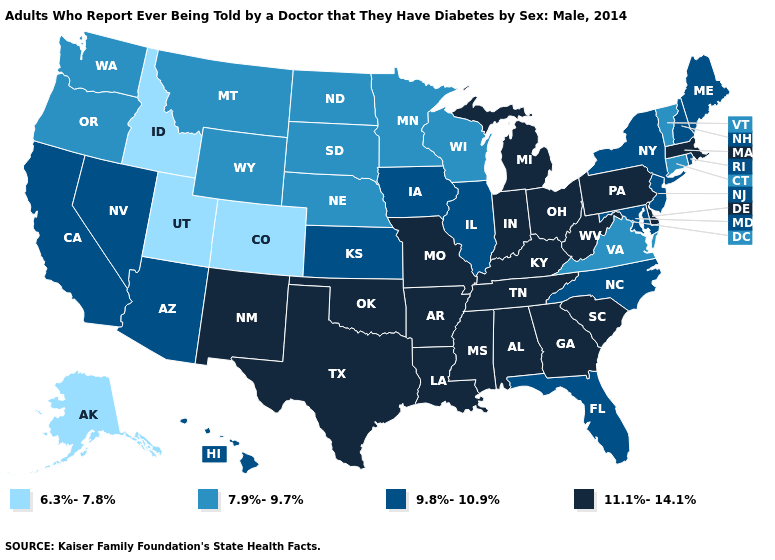Is the legend a continuous bar?
Give a very brief answer. No. Which states hav the highest value in the MidWest?
Write a very short answer. Indiana, Michigan, Missouri, Ohio. What is the value of Missouri?
Answer briefly. 11.1%-14.1%. What is the value of Texas?
Quick response, please. 11.1%-14.1%. Does West Virginia have the lowest value in the South?
Short answer required. No. Among the states that border New Jersey , does Pennsylvania have the highest value?
Write a very short answer. Yes. Does the map have missing data?
Quick response, please. No. Which states hav the highest value in the Northeast?
Short answer required. Massachusetts, Pennsylvania. What is the lowest value in states that border Delaware?
Give a very brief answer. 9.8%-10.9%. Does South Carolina have a higher value than Maine?
Keep it brief. Yes. Name the states that have a value in the range 6.3%-7.8%?
Quick response, please. Alaska, Colorado, Idaho, Utah. Which states have the lowest value in the MidWest?
Keep it brief. Minnesota, Nebraska, North Dakota, South Dakota, Wisconsin. What is the highest value in the USA?
Concise answer only. 11.1%-14.1%. Which states have the lowest value in the USA?
Short answer required. Alaska, Colorado, Idaho, Utah. What is the value of New Hampshire?
Answer briefly. 9.8%-10.9%. 